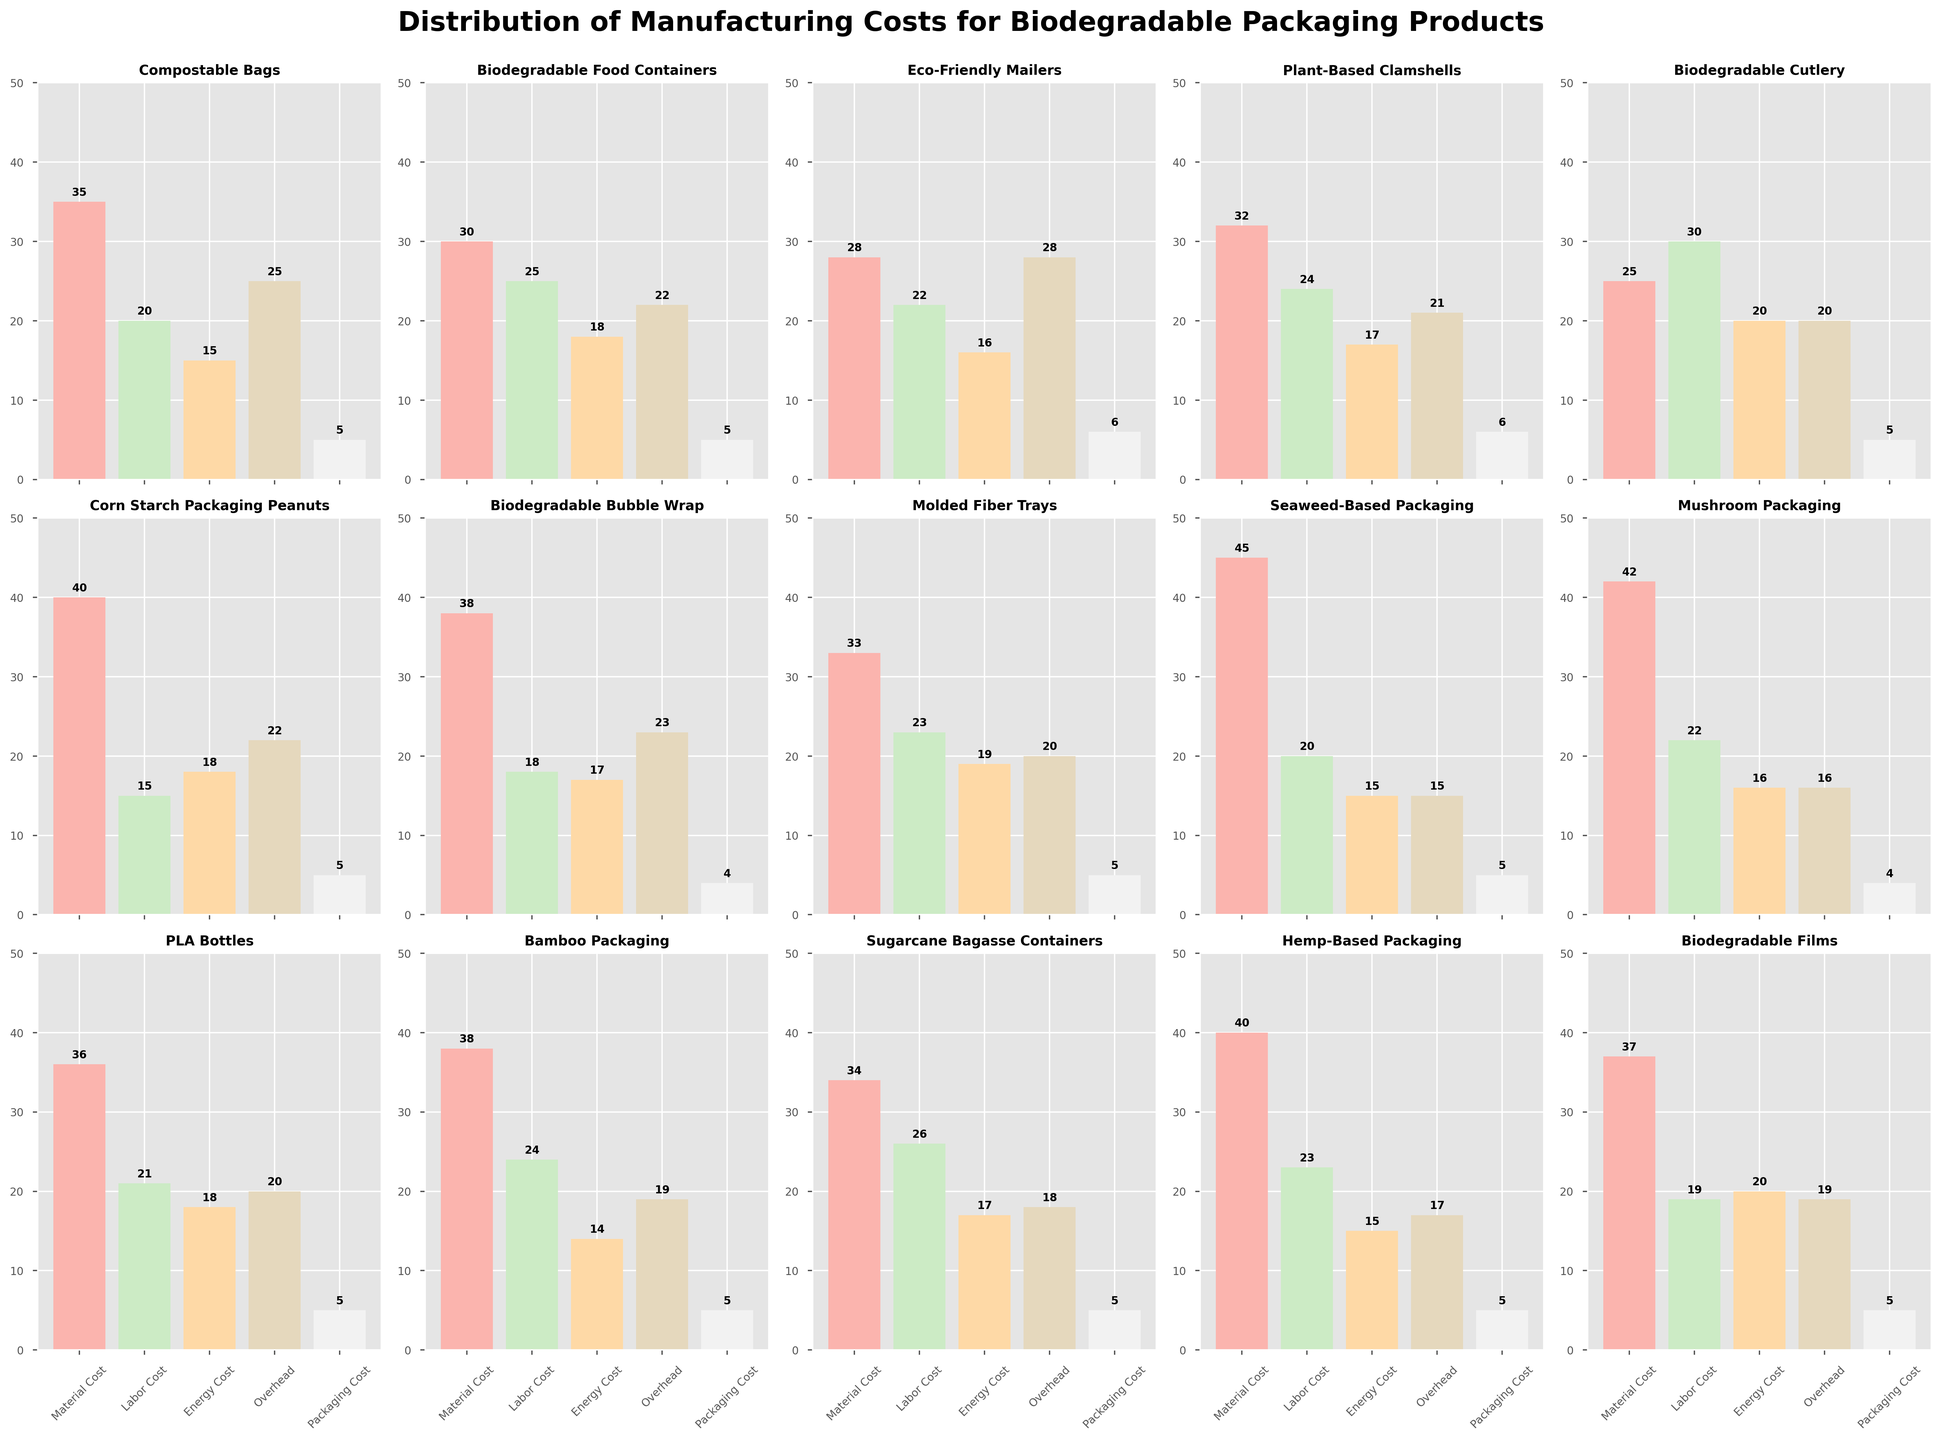Which product has the highest material cost? By observing the height of the bars for the 'Material Cost' category across all products, it is clear that 'Seaweed-Based Packaging' has the tallest bar.
Answer: Seaweed-Based Packaging Compare the labor costs of 'Compostable Bags' and 'Biodegradable Cutlery'. Which one is higher and by how much? 'Biodegradable Cutlery' has a labor cost of 30, while 'Compostable Bags' has a labor cost of 20. The difference is calculated as 30 - 20 = 10.
Answer: Biodegradable Cutlery by 10 Which product has the lowest energy cost and how much is it? By looking at the height of the bars in the 'Energy Cost' category, 'Bamboo Packaging' has the lowest bar, indicating an energy cost of 14.
Answer: Bamboo Packaging, 14 Sum the overhead costs of 'Eco-Friendly Mailers' and 'PLA Bottles'. What is the result? The overhead cost for 'Eco-Friendly Mailers' is 28 and for 'PLA Bottles' is 20. Summing these values gives 28 + 20 = 48.
Answer: 48 What is the average packaging cost across all products? Summing the packaging costs across all products: 5 + 5 + 6 + 6 + 5 + 5 + 4 + 5 + 5 + 4 + 5 + 5 + 5 + 5 + 5 = 75. There are 15 products, so the average is 75/15 = 5.
Answer: 5 Visualize the material cost of 'Corn Starch Packaging Peanuts' and 'Hemp-Based Packaging'. Which one is visually higher? The material cost bars show 'Hemp-Based Packaging' has a height of 40, while 'Corn Starch Packaging Peanuts' also has a height of 40. Both are equal.
Answer: Both are equal Calculate the difference between the highest and lowest overhead costs. The highest overhead cost is 28 (Eco-Friendly Mailers), and the lowest is 15 (Seaweed-Based Packaging). The difference is 28 - 15 = 13.
Answer: 13 How many products have an energy cost of 18? By counting the bars in the 'Energy Cost' category, 'Biodegradable Food Containers', 'Corn Starch Packaging Peanuts', and 'PLA Bottles' have an energy cost of 18.
Answer: 3 Which product has the highest labor cost and what is the value? By observing the bars for 'Labor Cost', 'Biodegradable Cutlery' has the highest labor cost with a value of 30.
Answer: Biodegradable Cutlery, 30 